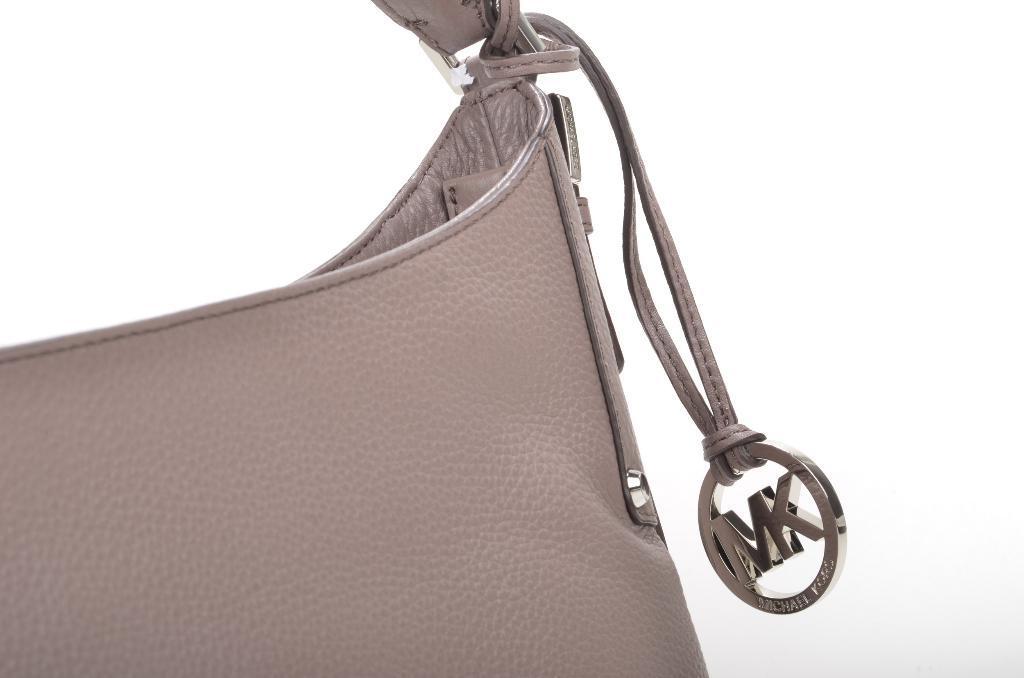Could you give a brief overview of what you see in this image? In this picture we can see a bag which is truncated. 